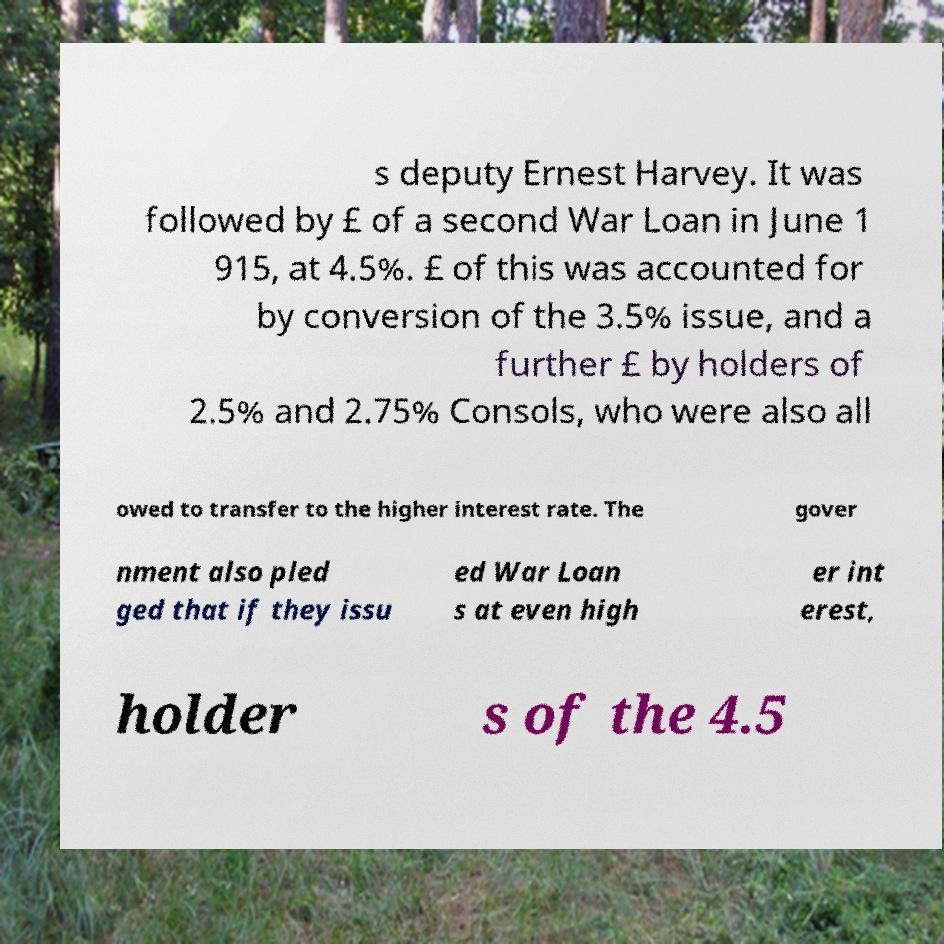What messages or text are displayed in this image? I need them in a readable, typed format. s deputy Ernest Harvey. It was followed by £ of a second War Loan in June 1 915, at 4.5%. £ of this was accounted for by conversion of the 3.5% issue, and a further £ by holders of 2.5% and 2.75% Consols, who were also all owed to transfer to the higher interest rate. The gover nment also pled ged that if they issu ed War Loan s at even high er int erest, holder s of the 4.5 